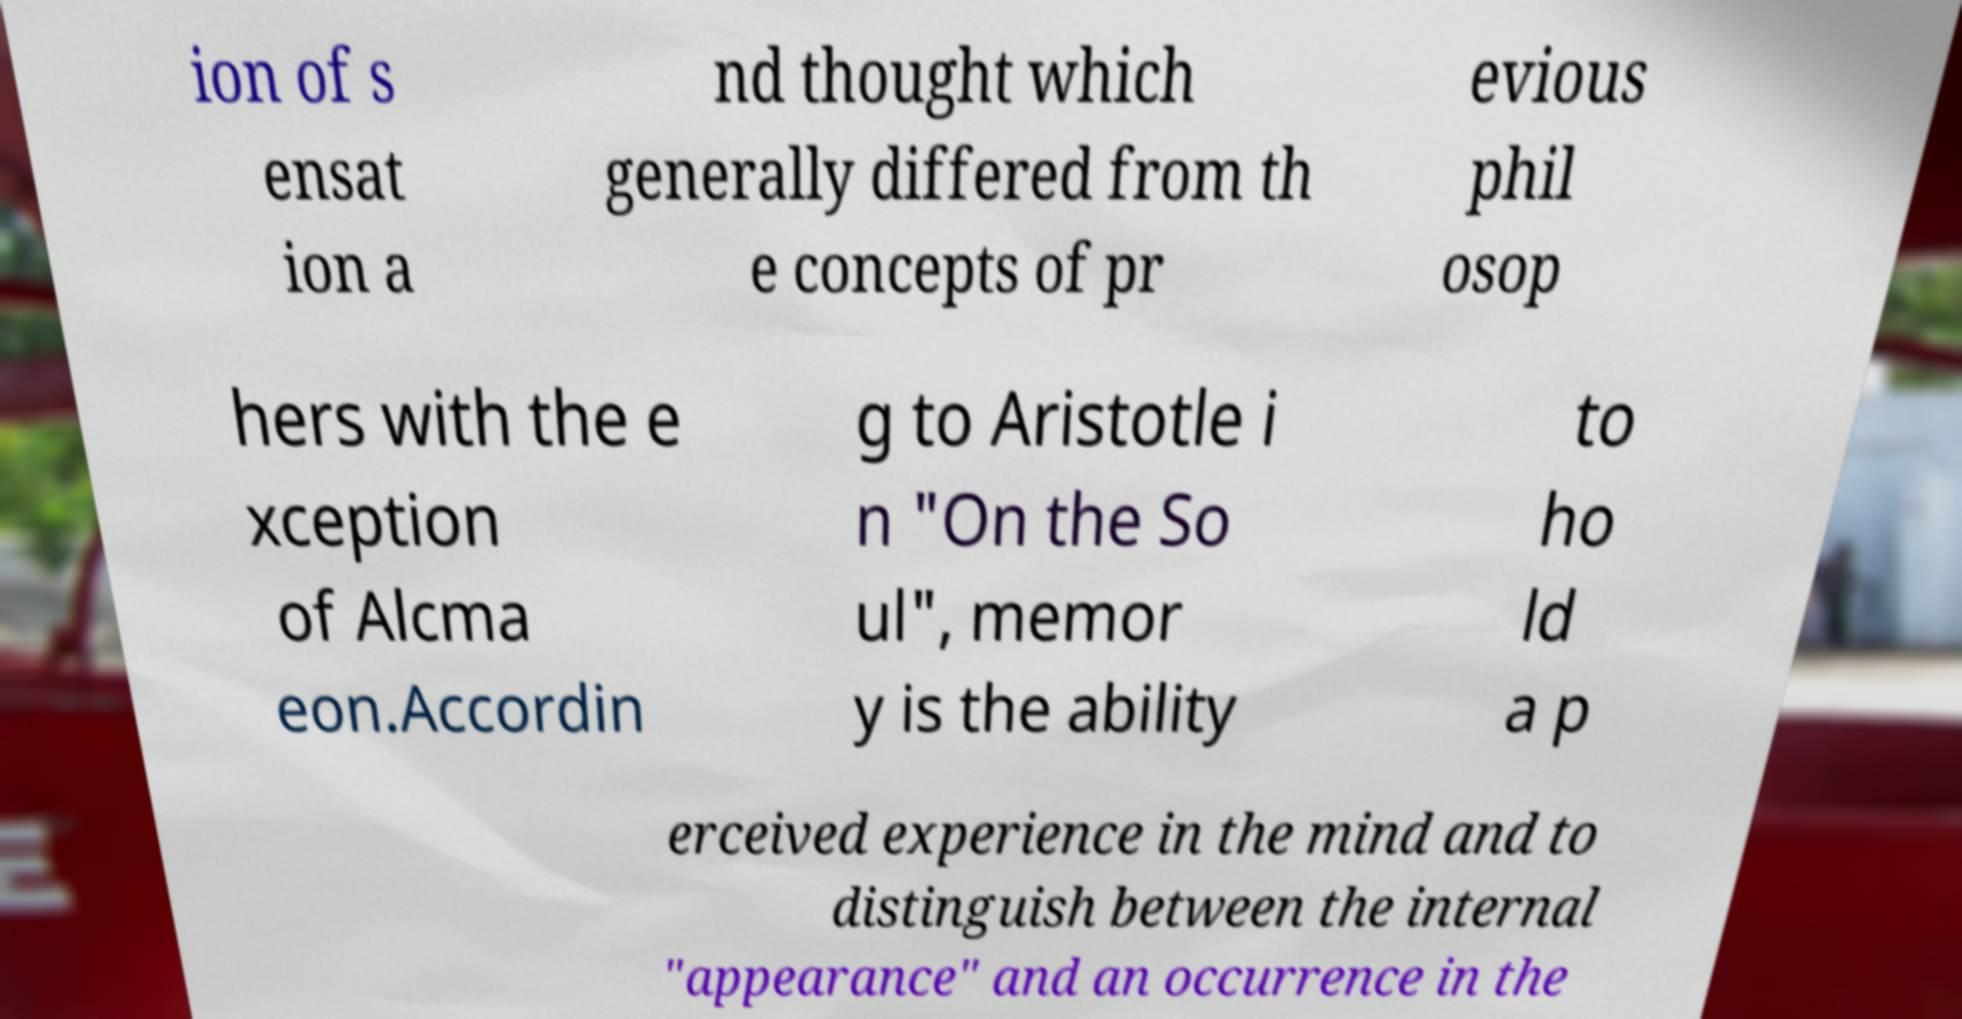Could you assist in decoding the text presented in this image and type it out clearly? ion of s ensat ion a nd thought which generally differed from th e concepts of pr evious phil osop hers with the e xception of Alcma eon.Accordin g to Aristotle i n "On the So ul", memor y is the ability to ho ld a p erceived experience in the mind and to distinguish between the internal "appearance" and an occurrence in the 